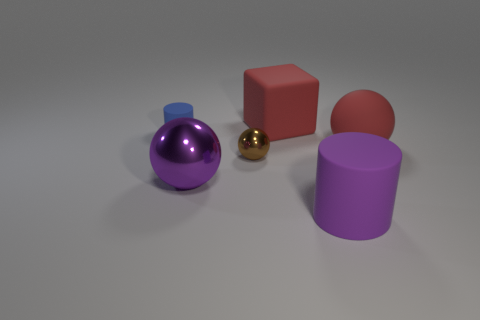Subtract all shiny spheres. How many spheres are left? 1 Add 4 big rubber cylinders. How many objects exist? 10 Subtract all brown balls. How many balls are left? 2 Subtract all cubes. How many objects are left? 5 Subtract 1 cylinders. How many cylinders are left? 1 Subtract all gray spheres. Subtract all blue cylinders. How many spheres are left? 3 Subtract all big purple metal objects. Subtract all purple matte cylinders. How many objects are left? 4 Add 4 big red matte blocks. How many big red matte blocks are left? 5 Add 1 small cyan blocks. How many small cyan blocks exist? 1 Subtract 1 purple balls. How many objects are left? 5 